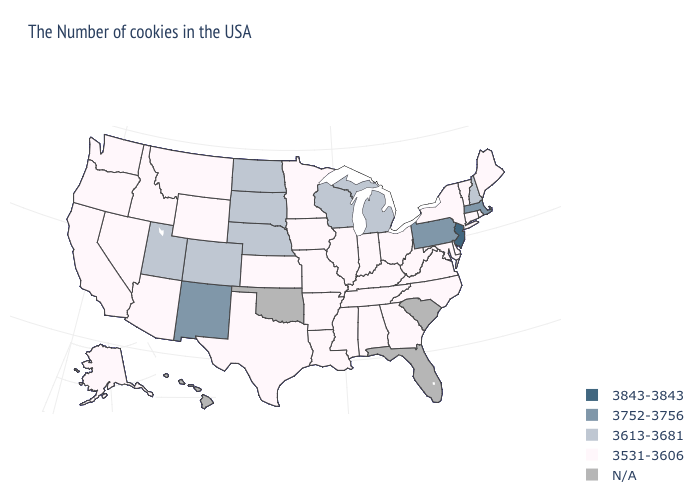What is the value of Delaware?
Quick response, please. 3531-3606. Name the states that have a value in the range 3613-3681?
Answer briefly. New Hampshire, Michigan, Wisconsin, Nebraska, South Dakota, North Dakota, Colorado, Utah. What is the highest value in states that border Indiana?
Short answer required. 3613-3681. What is the lowest value in states that border Connecticut?
Short answer required. 3531-3606. What is the value of Montana?
Concise answer only. 3531-3606. Which states hav the highest value in the Northeast?
Quick response, please. New Jersey. Name the states that have a value in the range 3752-3756?
Be succinct. Massachusetts, Pennsylvania, New Mexico. What is the value of New Mexico?
Short answer required. 3752-3756. Name the states that have a value in the range 3613-3681?
Write a very short answer. New Hampshire, Michigan, Wisconsin, Nebraska, South Dakota, North Dakota, Colorado, Utah. Which states have the lowest value in the Northeast?
Short answer required. Maine, Rhode Island, Vermont, Connecticut, New York. What is the highest value in the South ?
Be succinct. 3531-3606. Name the states that have a value in the range N/A?
Write a very short answer. South Carolina, Florida, Oklahoma, Hawaii. What is the highest value in states that border Kentucky?
Be succinct. 3531-3606. What is the value of Indiana?
Quick response, please. 3531-3606. Name the states that have a value in the range 3613-3681?
Short answer required. New Hampshire, Michigan, Wisconsin, Nebraska, South Dakota, North Dakota, Colorado, Utah. 